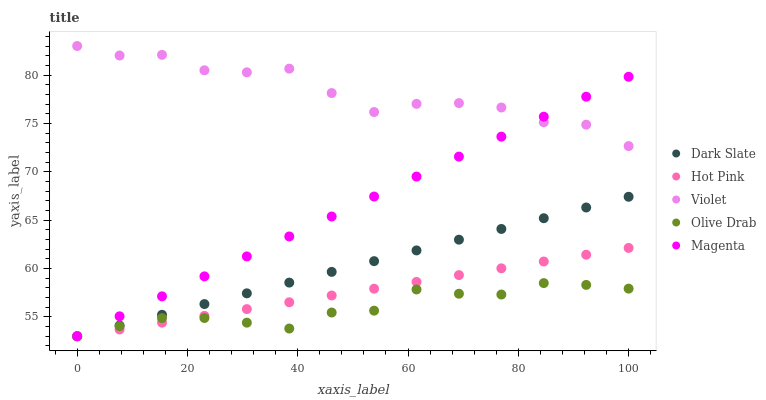Does Olive Drab have the minimum area under the curve?
Answer yes or no. Yes. Does Violet have the maximum area under the curve?
Answer yes or no. Yes. Does Magenta have the minimum area under the curve?
Answer yes or no. No. Does Magenta have the maximum area under the curve?
Answer yes or no. No. Is Hot Pink the smoothest?
Answer yes or no. Yes. Is Violet the roughest?
Answer yes or no. Yes. Is Magenta the smoothest?
Answer yes or no. No. Is Magenta the roughest?
Answer yes or no. No. Does Dark Slate have the lowest value?
Answer yes or no. Yes. Does Violet have the lowest value?
Answer yes or no. No. Does Violet have the highest value?
Answer yes or no. Yes. Does Magenta have the highest value?
Answer yes or no. No. Is Dark Slate less than Violet?
Answer yes or no. Yes. Is Violet greater than Olive Drab?
Answer yes or no. Yes. Does Magenta intersect Hot Pink?
Answer yes or no. Yes. Is Magenta less than Hot Pink?
Answer yes or no. No. Is Magenta greater than Hot Pink?
Answer yes or no. No. Does Dark Slate intersect Violet?
Answer yes or no. No. 